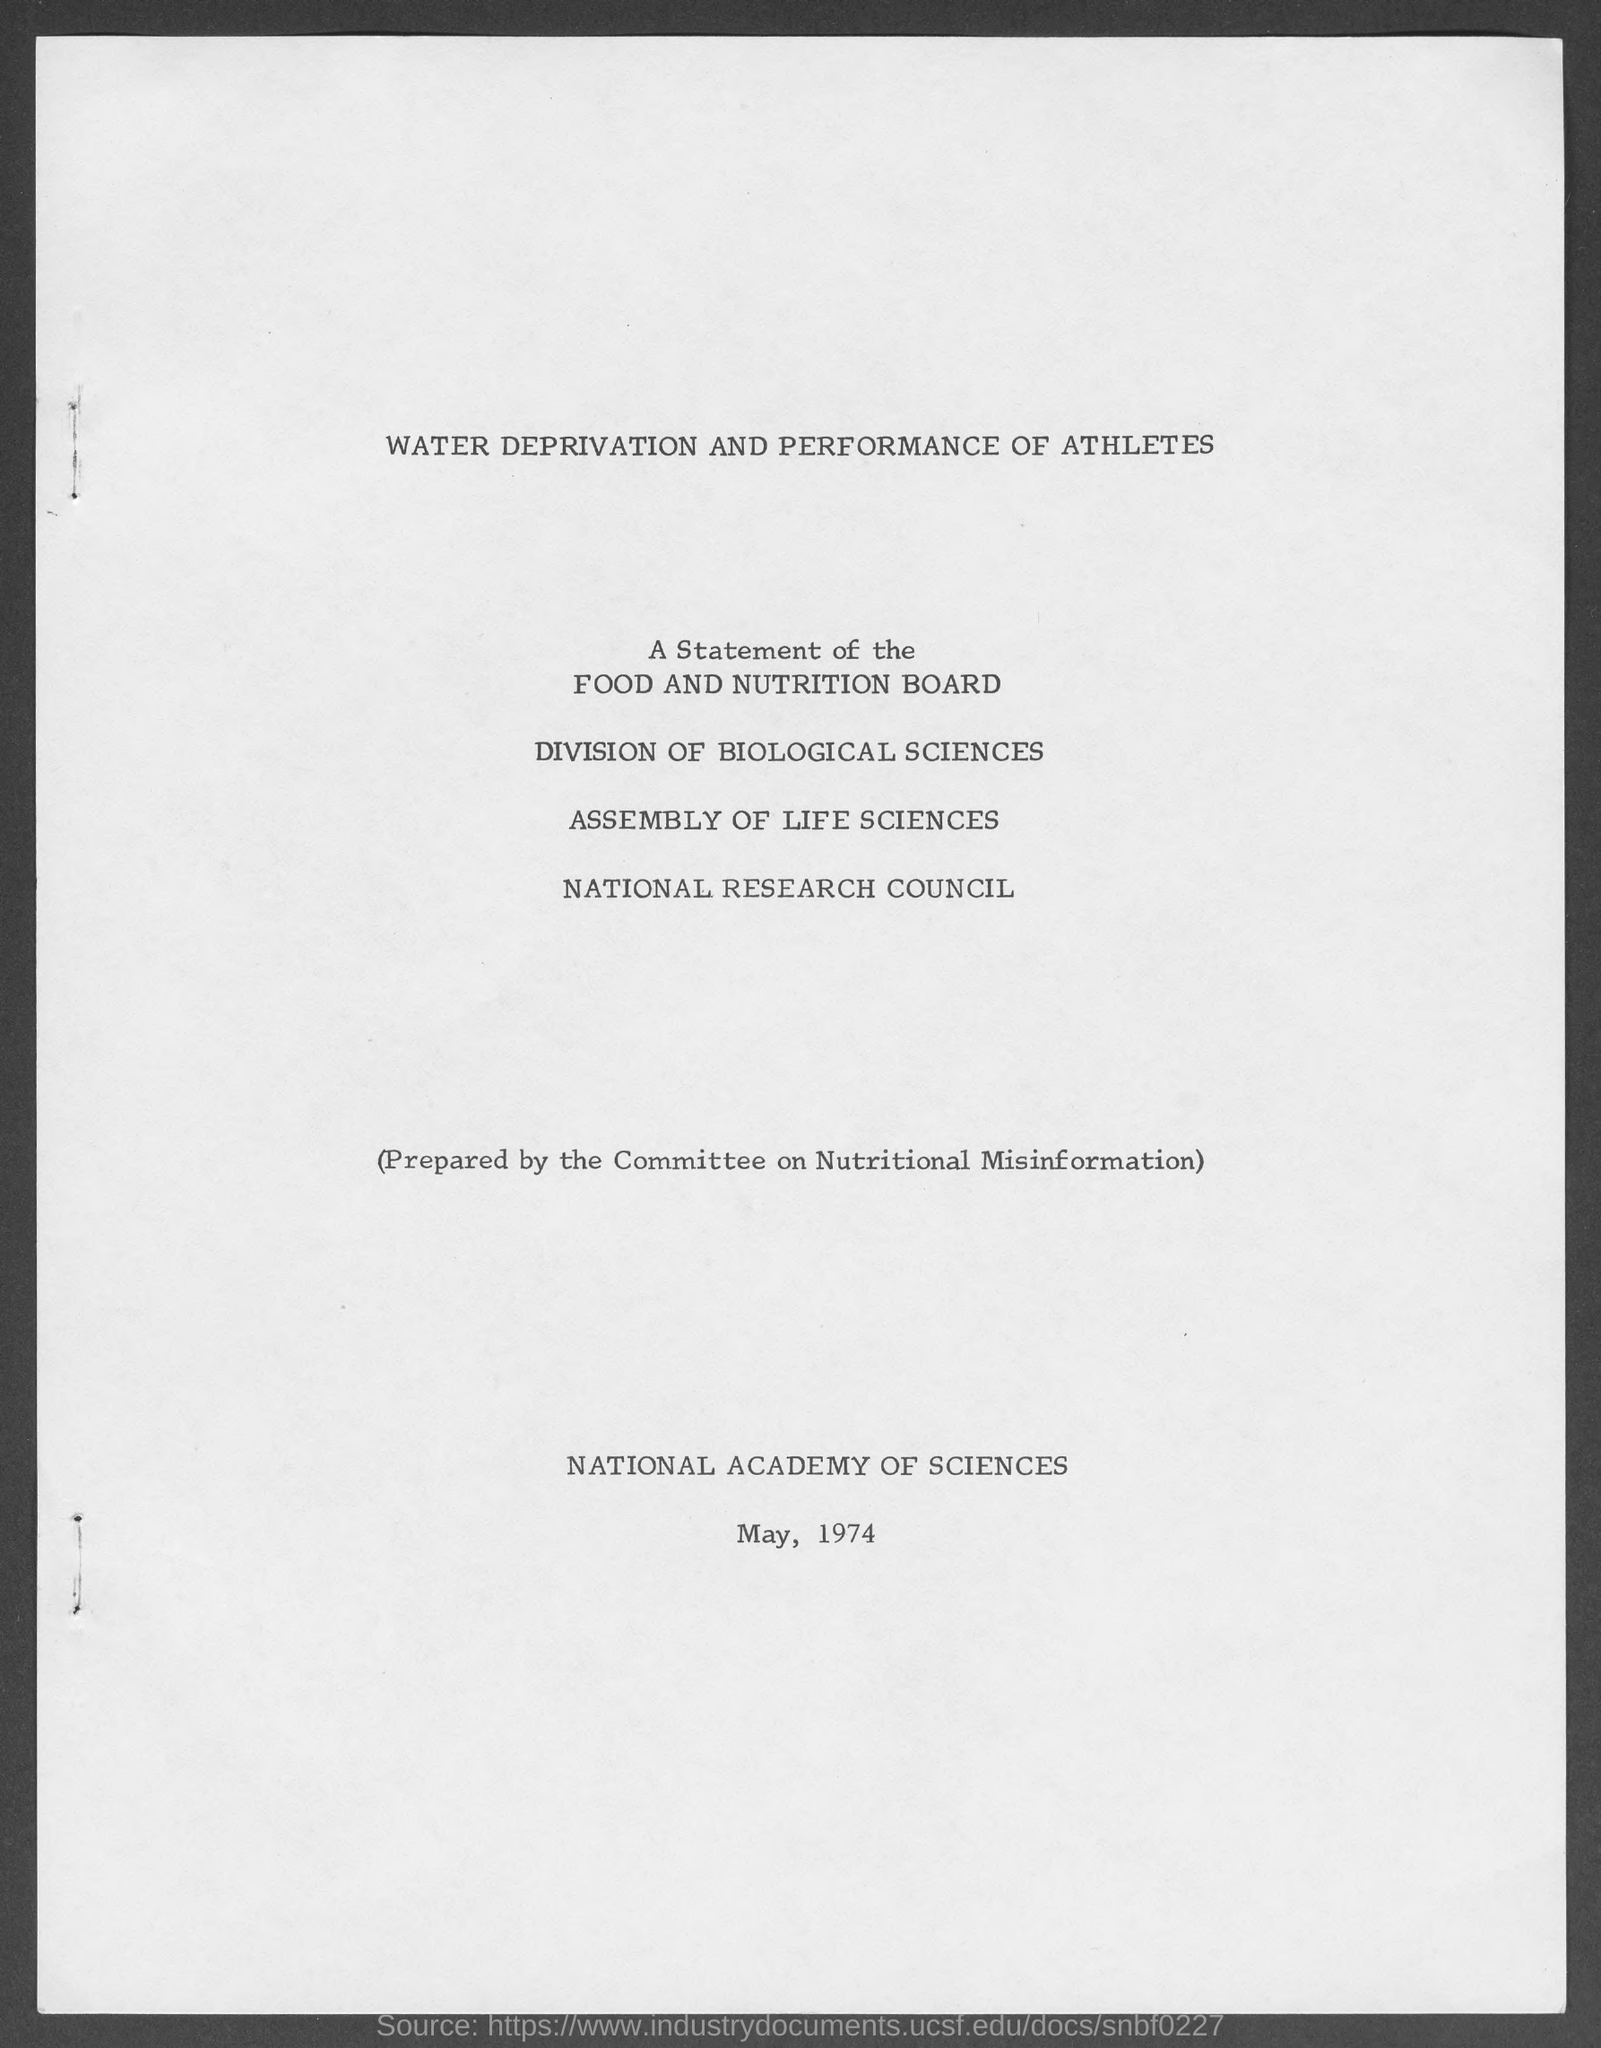What is month and year at bottom of the page ?
Provide a succinct answer. May, 1974. 